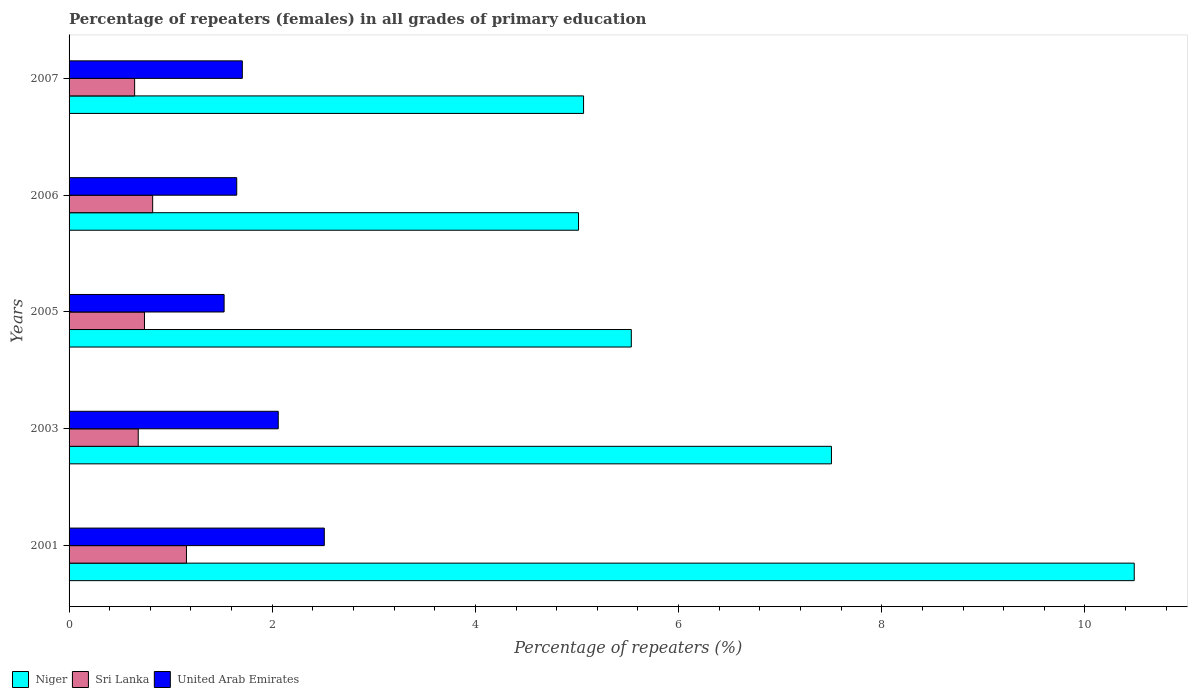How many different coloured bars are there?
Provide a succinct answer. 3. How many groups of bars are there?
Offer a very short reply. 5. Are the number of bars on each tick of the Y-axis equal?
Provide a short and direct response. Yes. How many bars are there on the 3rd tick from the top?
Offer a very short reply. 3. How many bars are there on the 1st tick from the bottom?
Provide a succinct answer. 3. What is the percentage of repeaters (females) in United Arab Emirates in 2006?
Offer a very short reply. 1.65. Across all years, what is the maximum percentage of repeaters (females) in United Arab Emirates?
Offer a terse response. 2.51. Across all years, what is the minimum percentage of repeaters (females) in Niger?
Your response must be concise. 5.01. In which year was the percentage of repeaters (females) in Sri Lanka minimum?
Provide a succinct answer. 2007. What is the total percentage of repeaters (females) in Sri Lanka in the graph?
Ensure brevity in your answer.  4.05. What is the difference between the percentage of repeaters (females) in Niger in 2001 and that in 2003?
Your response must be concise. 2.98. What is the difference between the percentage of repeaters (females) in United Arab Emirates in 2006 and the percentage of repeaters (females) in Sri Lanka in 2005?
Give a very brief answer. 0.91. What is the average percentage of repeaters (females) in United Arab Emirates per year?
Your answer should be compact. 1.89. In the year 2003, what is the difference between the percentage of repeaters (females) in Sri Lanka and percentage of repeaters (females) in Niger?
Your answer should be very brief. -6.82. What is the ratio of the percentage of repeaters (females) in Sri Lanka in 2001 to that in 2006?
Offer a terse response. 1.4. Is the difference between the percentage of repeaters (females) in Sri Lanka in 2003 and 2005 greater than the difference between the percentage of repeaters (females) in Niger in 2003 and 2005?
Make the answer very short. No. What is the difference between the highest and the second highest percentage of repeaters (females) in Niger?
Your answer should be very brief. 2.98. What is the difference between the highest and the lowest percentage of repeaters (females) in Niger?
Ensure brevity in your answer.  5.47. In how many years, is the percentage of repeaters (females) in United Arab Emirates greater than the average percentage of repeaters (females) in United Arab Emirates taken over all years?
Your answer should be very brief. 2. What does the 3rd bar from the top in 2007 represents?
Offer a terse response. Niger. What does the 2nd bar from the bottom in 2001 represents?
Give a very brief answer. Sri Lanka. How many years are there in the graph?
Keep it short and to the point. 5. What is the difference between two consecutive major ticks on the X-axis?
Provide a short and direct response. 2. Are the values on the major ticks of X-axis written in scientific E-notation?
Offer a terse response. No. Does the graph contain any zero values?
Give a very brief answer. No. Does the graph contain grids?
Keep it short and to the point. No. How many legend labels are there?
Provide a succinct answer. 3. What is the title of the graph?
Your answer should be very brief. Percentage of repeaters (females) in all grades of primary education. What is the label or title of the X-axis?
Provide a short and direct response. Percentage of repeaters (%). What is the Percentage of repeaters (%) of Niger in 2001?
Give a very brief answer. 10.48. What is the Percentage of repeaters (%) of Sri Lanka in 2001?
Your answer should be very brief. 1.16. What is the Percentage of repeaters (%) in United Arab Emirates in 2001?
Offer a terse response. 2.51. What is the Percentage of repeaters (%) of Niger in 2003?
Make the answer very short. 7.5. What is the Percentage of repeaters (%) in Sri Lanka in 2003?
Offer a terse response. 0.68. What is the Percentage of repeaters (%) in United Arab Emirates in 2003?
Your answer should be very brief. 2.06. What is the Percentage of repeaters (%) in Niger in 2005?
Your answer should be very brief. 5.53. What is the Percentage of repeaters (%) in Sri Lanka in 2005?
Your response must be concise. 0.74. What is the Percentage of repeaters (%) of United Arab Emirates in 2005?
Offer a very short reply. 1.53. What is the Percentage of repeaters (%) of Niger in 2006?
Offer a very short reply. 5.01. What is the Percentage of repeaters (%) of Sri Lanka in 2006?
Your answer should be compact. 0.82. What is the Percentage of repeaters (%) of United Arab Emirates in 2006?
Provide a short and direct response. 1.65. What is the Percentage of repeaters (%) of Niger in 2007?
Your response must be concise. 5.06. What is the Percentage of repeaters (%) of Sri Lanka in 2007?
Provide a short and direct response. 0.65. What is the Percentage of repeaters (%) in United Arab Emirates in 2007?
Your answer should be compact. 1.71. Across all years, what is the maximum Percentage of repeaters (%) in Niger?
Keep it short and to the point. 10.48. Across all years, what is the maximum Percentage of repeaters (%) of Sri Lanka?
Provide a succinct answer. 1.16. Across all years, what is the maximum Percentage of repeaters (%) in United Arab Emirates?
Offer a terse response. 2.51. Across all years, what is the minimum Percentage of repeaters (%) in Niger?
Your answer should be very brief. 5.01. Across all years, what is the minimum Percentage of repeaters (%) of Sri Lanka?
Your answer should be very brief. 0.65. Across all years, what is the minimum Percentage of repeaters (%) in United Arab Emirates?
Offer a very short reply. 1.53. What is the total Percentage of repeaters (%) of Niger in the graph?
Ensure brevity in your answer.  33.6. What is the total Percentage of repeaters (%) in Sri Lanka in the graph?
Provide a short and direct response. 4.05. What is the total Percentage of repeaters (%) in United Arab Emirates in the graph?
Make the answer very short. 9.45. What is the difference between the Percentage of repeaters (%) of Niger in 2001 and that in 2003?
Your response must be concise. 2.98. What is the difference between the Percentage of repeaters (%) of Sri Lanka in 2001 and that in 2003?
Provide a succinct answer. 0.47. What is the difference between the Percentage of repeaters (%) in United Arab Emirates in 2001 and that in 2003?
Your answer should be very brief. 0.45. What is the difference between the Percentage of repeaters (%) of Niger in 2001 and that in 2005?
Provide a short and direct response. 4.95. What is the difference between the Percentage of repeaters (%) in Sri Lanka in 2001 and that in 2005?
Make the answer very short. 0.41. What is the difference between the Percentage of repeaters (%) of United Arab Emirates in 2001 and that in 2005?
Your answer should be compact. 0.99. What is the difference between the Percentage of repeaters (%) in Niger in 2001 and that in 2006?
Your answer should be very brief. 5.47. What is the difference between the Percentage of repeaters (%) of Sri Lanka in 2001 and that in 2006?
Provide a short and direct response. 0.33. What is the difference between the Percentage of repeaters (%) in United Arab Emirates in 2001 and that in 2006?
Make the answer very short. 0.86. What is the difference between the Percentage of repeaters (%) in Niger in 2001 and that in 2007?
Give a very brief answer. 5.42. What is the difference between the Percentage of repeaters (%) of Sri Lanka in 2001 and that in 2007?
Your answer should be very brief. 0.51. What is the difference between the Percentage of repeaters (%) of United Arab Emirates in 2001 and that in 2007?
Your answer should be very brief. 0.81. What is the difference between the Percentage of repeaters (%) in Niger in 2003 and that in 2005?
Offer a terse response. 1.97. What is the difference between the Percentage of repeaters (%) of Sri Lanka in 2003 and that in 2005?
Your response must be concise. -0.06. What is the difference between the Percentage of repeaters (%) in United Arab Emirates in 2003 and that in 2005?
Your response must be concise. 0.53. What is the difference between the Percentage of repeaters (%) of Niger in 2003 and that in 2006?
Your answer should be very brief. 2.49. What is the difference between the Percentage of repeaters (%) in Sri Lanka in 2003 and that in 2006?
Provide a short and direct response. -0.14. What is the difference between the Percentage of repeaters (%) in United Arab Emirates in 2003 and that in 2006?
Give a very brief answer. 0.41. What is the difference between the Percentage of repeaters (%) of Niger in 2003 and that in 2007?
Provide a short and direct response. 2.44. What is the difference between the Percentage of repeaters (%) of Sri Lanka in 2003 and that in 2007?
Your answer should be very brief. 0.04. What is the difference between the Percentage of repeaters (%) of United Arab Emirates in 2003 and that in 2007?
Keep it short and to the point. 0.35. What is the difference between the Percentage of repeaters (%) of Niger in 2005 and that in 2006?
Offer a very short reply. 0.52. What is the difference between the Percentage of repeaters (%) in Sri Lanka in 2005 and that in 2006?
Give a very brief answer. -0.08. What is the difference between the Percentage of repeaters (%) in United Arab Emirates in 2005 and that in 2006?
Keep it short and to the point. -0.12. What is the difference between the Percentage of repeaters (%) in Niger in 2005 and that in 2007?
Offer a terse response. 0.47. What is the difference between the Percentage of repeaters (%) of Sri Lanka in 2005 and that in 2007?
Give a very brief answer. 0.1. What is the difference between the Percentage of repeaters (%) of United Arab Emirates in 2005 and that in 2007?
Offer a terse response. -0.18. What is the difference between the Percentage of repeaters (%) in Niger in 2006 and that in 2007?
Your answer should be very brief. -0.05. What is the difference between the Percentage of repeaters (%) in Sri Lanka in 2006 and that in 2007?
Ensure brevity in your answer.  0.18. What is the difference between the Percentage of repeaters (%) in United Arab Emirates in 2006 and that in 2007?
Give a very brief answer. -0.06. What is the difference between the Percentage of repeaters (%) of Niger in 2001 and the Percentage of repeaters (%) of Sri Lanka in 2003?
Keep it short and to the point. 9.8. What is the difference between the Percentage of repeaters (%) of Niger in 2001 and the Percentage of repeaters (%) of United Arab Emirates in 2003?
Your answer should be very brief. 8.43. What is the difference between the Percentage of repeaters (%) in Sri Lanka in 2001 and the Percentage of repeaters (%) in United Arab Emirates in 2003?
Offer a very short reply. -0.9. What is the difference between the Percentage of repeaters (%) of Niger in 2001 and the Percentage of repeaters (%) of Sri Lanka in 2005?
Give a very brief answer. 9.74. What is the difference between the Percentage of repeaters (%) in Niger in 2001 and the Percentage of repeaters (%) in United Arab Emirates in 2005?
Offer a terse response. 8.96. What is the difference between the Percentage of repeaters (%) in Sri Lanka in 2001 and the Percentage of repeaters (%) in United Arab Emirates in 2005?
Make the answer very short. -0.37. What is the difference between the Percentage of repeaters (%) of Niger in 2001 and the Percentage of repeaters (%) of Sri Lanka in 2006?
Offer a very short reply. 9.66. What is the difference between the Percentage of repeaters (%) in Niger in 2001 and the Percentage of repeaters (%) in United Arab Emirates in 2006?
Offer a terse response. 8.83. What is the difference between the Percentage of repeaters (%) in Sri Lanka in 2001 and the Percentage of repeaters (%) in United Arab Emirates in 2006?
Give a very brief answer. -0.49. What is the difference between the Percentage of repeaters (%) in Niger in 2001 and the Percentage of repeaters (%) in Sri Lanka in 2007?
Give a very brief answer. 9.84. What is the difference between the Percentage of repeaters (%) in Niger in 2001 and the Percentage of repeaters (%) in United Arab Emirates in 2007?
Give a very brief answer. 8.78. What is the difference between the Percentage of repeaters (%) of Sri Lanka in 2001 and the Percentage of repeaters (%) of United Arab Emirates in 2007?
Your answer should be very brief. -0.55. What is the difference between the Percentage of repeaters (%) in Niger in 2003 and the Percentage of repeaters (%) in Sri Lanka in 2005?
Your answer should be compact. 6.76. What is the difference between the Percentage of repeaters (%) in Niger in 2003 and the Percentage of repeaters (%) in United Arab Emirates in 2005?
Keep it short and to the point. 5.98. What is the difference between the Percentage of repeaters (%) in Sri Lanka in 2003 and the Percentage of repeaters (%) in United Arab Emirates in 2005?
Ensure brevity in your answer.  -0.85. What is the difference between the Percentage of repeaters (%) of Niger in 2003 and the Percentage of repeaters (%) of Sri Lanka in 2006?
Offer a terse response. 6.68. What is the difference between the Percentage of repeaters (%) of Niger in 2003 and the Percentage of repeaters (%) of United Arab Emirates in 2006?
Keep it short and to the point. 5.85. What is the difference between the Percentage of repeaters (%) in Sri Lanka in 2003 and the Percentage of repeaters (%) in United Arab Emirates in 2006?
Your response must be concise. -0.97. What is the difference between the Percentage of repeaters (%) of Niger in 2003 and the Percentage of repeaters (%) of Sri Lanka in 2007?
Offer a very short reply. 6.86. What is the difference between the Percentage of repeaters (%) of Niger in 2003 and the Percentage of repeaters (%) of United Arab Emirates in 2007?
Offer a very short reply. 5.8. What is the difference between the Percentage of repeaters (%) of Sri Lanka in 2003 and the Percentage of repeaters (%) of United Arab Emirates in 2007?
Offer a terse response. -1.02. What is the difference between the Percentage of repeaters (%) in Niger in 2005 and the Percentage of repeaters (%) in Sri Lanka in 2006?
Provide a succinct answer. 4.71. What is the difference between the Percentage of repeaters (%) of Niger in 2005 and the Percentage of repeaters (%) of United Arab Emirates in 2006?
Your answer should be compact. 3.88. What is the difference between the Percentage of repeaters (%) in Sri Lanka in 2005 and the Percentage of repeaters (%) in United Arab Emirates in 2006?
Provide a succinct answer. -0.91. What is the difference between the Percentage of repeaters (%) of Niger in 2005 and the Percentage of repeaters (%) of Sri Lanka in 2007?
Your answer should be very brief. 4.89. What is the difference between the Percentage of repeaters (%) in Niger in 2005 and the Percentage of repeaters (%) in United Arab Emirates in 2007?
Make the answer very short. 3.83. What is the difference between the Percentage of repeaters (%) in Sri Lanka in 2005 and the Percentage of repeaters (%) in United Arab Emirates in 2007?
Make the answer very short. -0.96. What is the difference between the Percentage of repeaters (%) in Niger in 2006 and the Percentage of repeaters (%) in Sri Lanka in 2007?
Offer a terse response. 4.37. What is the difference between the Percentage of repeaters (%) of Niger in 2006 and the Percentage of repeaters (%) of United Arab Emirates in 2007?
Keep it short and to the point. 3.31. What is the difference between the Percentage of repeaters (%) of Sri Lanka in 2006 and the Percentage of repeaters (%) of United Arab Emirates in 2007?
Keep it short and to the point. -0.88. What is the average Percentage of repeaters (%) in Niger per year?
Your answer should be very brief. 6.72. What is the average Percentage of repeaters (%) in Sri Lanka per year?
Give a very brief answer. 0.81. What is the average Percentage of repeaters (%) of United Arab Emirates per year?
Offer a terse response. 1.89. In the year 2001, what is the difference between the Percentage of repeaters (%) in Niger and Percentage of repeaters (%) in Sri Lanka?
Provide a succinct answer. 9.33. In the year 2001, what is the difference between the Percentage of repeaters (%) of Niger and Percentage of repeaters (%) of United Arab Emirates?
Ensure brevity in your answer.  7.97. In the year 2001, what is the difference between the Percentage of repeaters (%) of Sri Lanka and Percentage of repeaters (%) of United Arab Emirates?
Your response must be concise. -1.36. In the year 2003, what is the difference between the Percentage of repeaters (%) of Niger and Percentage of repeaters (%) of Sri Lanka?
Provide a succinct answer. 6.82. In the year 2003, what is the difference between the Percentage of repeaters (%) of Niger and Percentage of repeaters (%) of United Arab Emirates?
Provide a short and direct response. 5.45. In the year 2003, what is the difference between the Percentage of repeaters (%) of Sri Lanka and Percentage of repeaters (%) of United Arab Emirates?
Provide a succinct answer. -1.38. In the year 2005, what is the difference between the Percentage of repeaters (%) in Niger and Percentage of repeaters (%) in Sri Lanka?
Provide a succinct answer. 4.79. In the year 2005, what is the difference between the Percentage of repeaters (%) in Niger and Percentage of repeaters (%) in United Arab Emirates?
Offer a very short reply. 4.01. In the year 2005, what is the difference between the Percentage of repeaters (%) of Sri Lanka and Percentage of repeaters (%) of United Arab Emirates?
Provide a short and direct response. -0.78. In the year 2006, what is the difference between the Percentage of repeaters (%) in Niger and Percentage of repeaters (%) in Sri Lanka?
Your response must be concise. 4.19. In the year 2006, what is the difference between the Percentage of repeaters (%) of Niger and Percentage of repeaters (%) of United Arab Emirates?
Your response must be concise. 3.36. In the year 2006, what is the difference between the Percentage of repeaters (%) of Sri Lanka and Percentage of repeaters (%) of United Arab Emirates?
Make the answer very short. -0.83. In the year 2007, what is the difference between the Percentage of repeaters (%) in Niger and Percentage of repeaters (%) in Sri Lanka?
Offer a very short reply. 4.42. In the year 2007, what is the difference between the Percentage of repeaters (%) in Niger and Percentage of repeaters (%) in United Arab Emirates?
Your answer should be very brief. 3.36. In the year 2007, what is the difference between the Percentage of repeaters (%) of Sri Lanka and Percentage of repeaters (%) of United Arab Emirates?
Make the answer very short. -1.06. What is the ratio of the Percentage of repeaters (%) of Niger in 2001 to that in 2003?
Ensure brevity in your answer.  1.4. What is the ratio of the Percentage of repeaters (%) in Sri Lanka in 2001 to that in 2003?
Offer a terse response. 1.7. What is the ratio of the Percentage of repeaters (%) in United Arab Emirates in 2001 to that in 2003?
Offer a very short reply. 1.22. What is the ratio of the Percentage of repeaters (%) in Niger in 2001 to that in 2005?
Provide a short and direct response. 1.89. What is the ratio of the Percentage of repeaters (%) of Sri Lanka in 2001 to that in 2005?
Offer a terse response. 1.56. What is the ratio of the Percentage of repeaters (%) in United Arab Emirates in 2001 to that in 2005?
Ensure brevity in your answer.  1.65. What is the ratio of the Percentage of repeaters (%) of Niger in 2001 to that in 2006?
Provide a short and direct response. 2.09. What is the ratio of the Percentage of repeaters (%) in Sri Lanka in 2001 to that in 2006?
Your response must be concise. 1.4. What is the ratio of the Percentage of repeaters (%) of United Arab Emirates in 2001 to that in 2006?
Make the answer very short. 1.52. What is the ratio of the Percentage of repeaters (%) in Niger in 2001 to that in 2007?
Provide a succinct answer. 2.07. What is the ratio of the Percentage of repeaters (%) of Sri Lanka in 2001 to that in 2007?
Ensure brevity in your answer.  1.79. What is the ratio of the Percentage of repeaters (%) of United Arab Emirates in 2001 to that in 2007?
Ensure brevity in your answer.  1.47. What is the ratio of the Percentage of repeaters (%) in Niger in 2003 to that in 2005?
Your answer should be very brief. 1.36. What is the ratio of the Percentage of repeaters (%) of Sri Lanka in 2003 to that in 2005?
Keep it short and to the point. 0.92. What is the ratio of the Percentage of repeaters (%) in United Arab Emirates in 2003 to that in 2005?
Make the answer very short. 1.35. What is the ratio of the Percentage of repeaters (%) of Niger in 2003 to that in 2006?
Provide a succinct answer. 1.5. What is the ratio of the Percentage of repeaters (%) of Sri Lanka in 2003 to that in 2006?
Offer a terse response. 0.83. What is the ratio of the Percentage of repeaters (%) of United Arab Emirates in 2003 to that in 2006?
Your answer should be very brief. 1.25. What is the ratio of the Percentage of repeaters (%) in Niger in 2003 to that in 2007?
Your answer should be very brief. 1.48. What is the ratio of the Percentage of repeaters (%) in Sri Lanka in 2003 to that in 2007?
Provide a short and direct response. 1.05. What is the ratio of the Percentage of repeaters (%) of United Arab Emirates in 2003 to that in 2007?
Your answer should be compact. 1.21. What is the ratio of the Percentage of repeaters (%) of Niger in 2005 to that in 2006?
Provide a short and direct response. 1.1. What is the ratio of the Percentage of repeaters (%) of Sri Lanka in 2005 to that in 2006?
Offer a terse response. 0.9. What is the ratio of the Percentage of repeaters (%) in United Arab Emirates in 2005 to that in 2006?
Provide a succinct answer. 0.92. What is the ratio of the Percentage of repeaters (%) of Niger in 2005 to that in 2007?
Provide a short and direct response. 1.09. What is the ratio of the Percentage of repeaters (%) in Sri Lanka in 2005 to that in 2007?
Ensure brevity in your answer.  1.15. What is the ratio of the Percentage of repeaters (%) of United Arab Emirates in 2005 to that in 2007?
Your answer should be compact. 0.89. What is the ratio of the Percentage of repeaters (%) of Niger in 2006 to that in 2007?
Give a very brief answer. 0.99. What is the ratio of the Percentage of repeaters (%) in Sri Lanka in 2006 to that in 2007?
Provide a short and direct response. 1.28. What is the ratio of the Percentage of repeaters (%) in United Arab Emirates in 2006 to that in 2007?
Offer a very short reply. 0.97. What is the difference between the highest and the second highest Percentage of repeaters (%) of Niger?
Provide a short and direct response. 2.98. What is the difference between the highest and the second highest Percentage of repeaters (%) in Sri Lanka?
Keep it short and to the point. 0.33. What is the difference between the highest and the second highest Percentage of repeaters (%) of United Arab Emirates?
Keep it short and to the point. 0.45. What is the difference between the highest and the lowest Percentage of repeaters (%) in Niger?
Your answer should be very brief. 5.47. What is the difference between the highest and the lowest Percentage of repeaters (%) of Sri Lanka?
Keep it short and to the point. 0.51. What is the difference between the highest and the lowest Percentage of repeaters (%) of United Arab Emirates?
Make the answer very short. 0.99. 